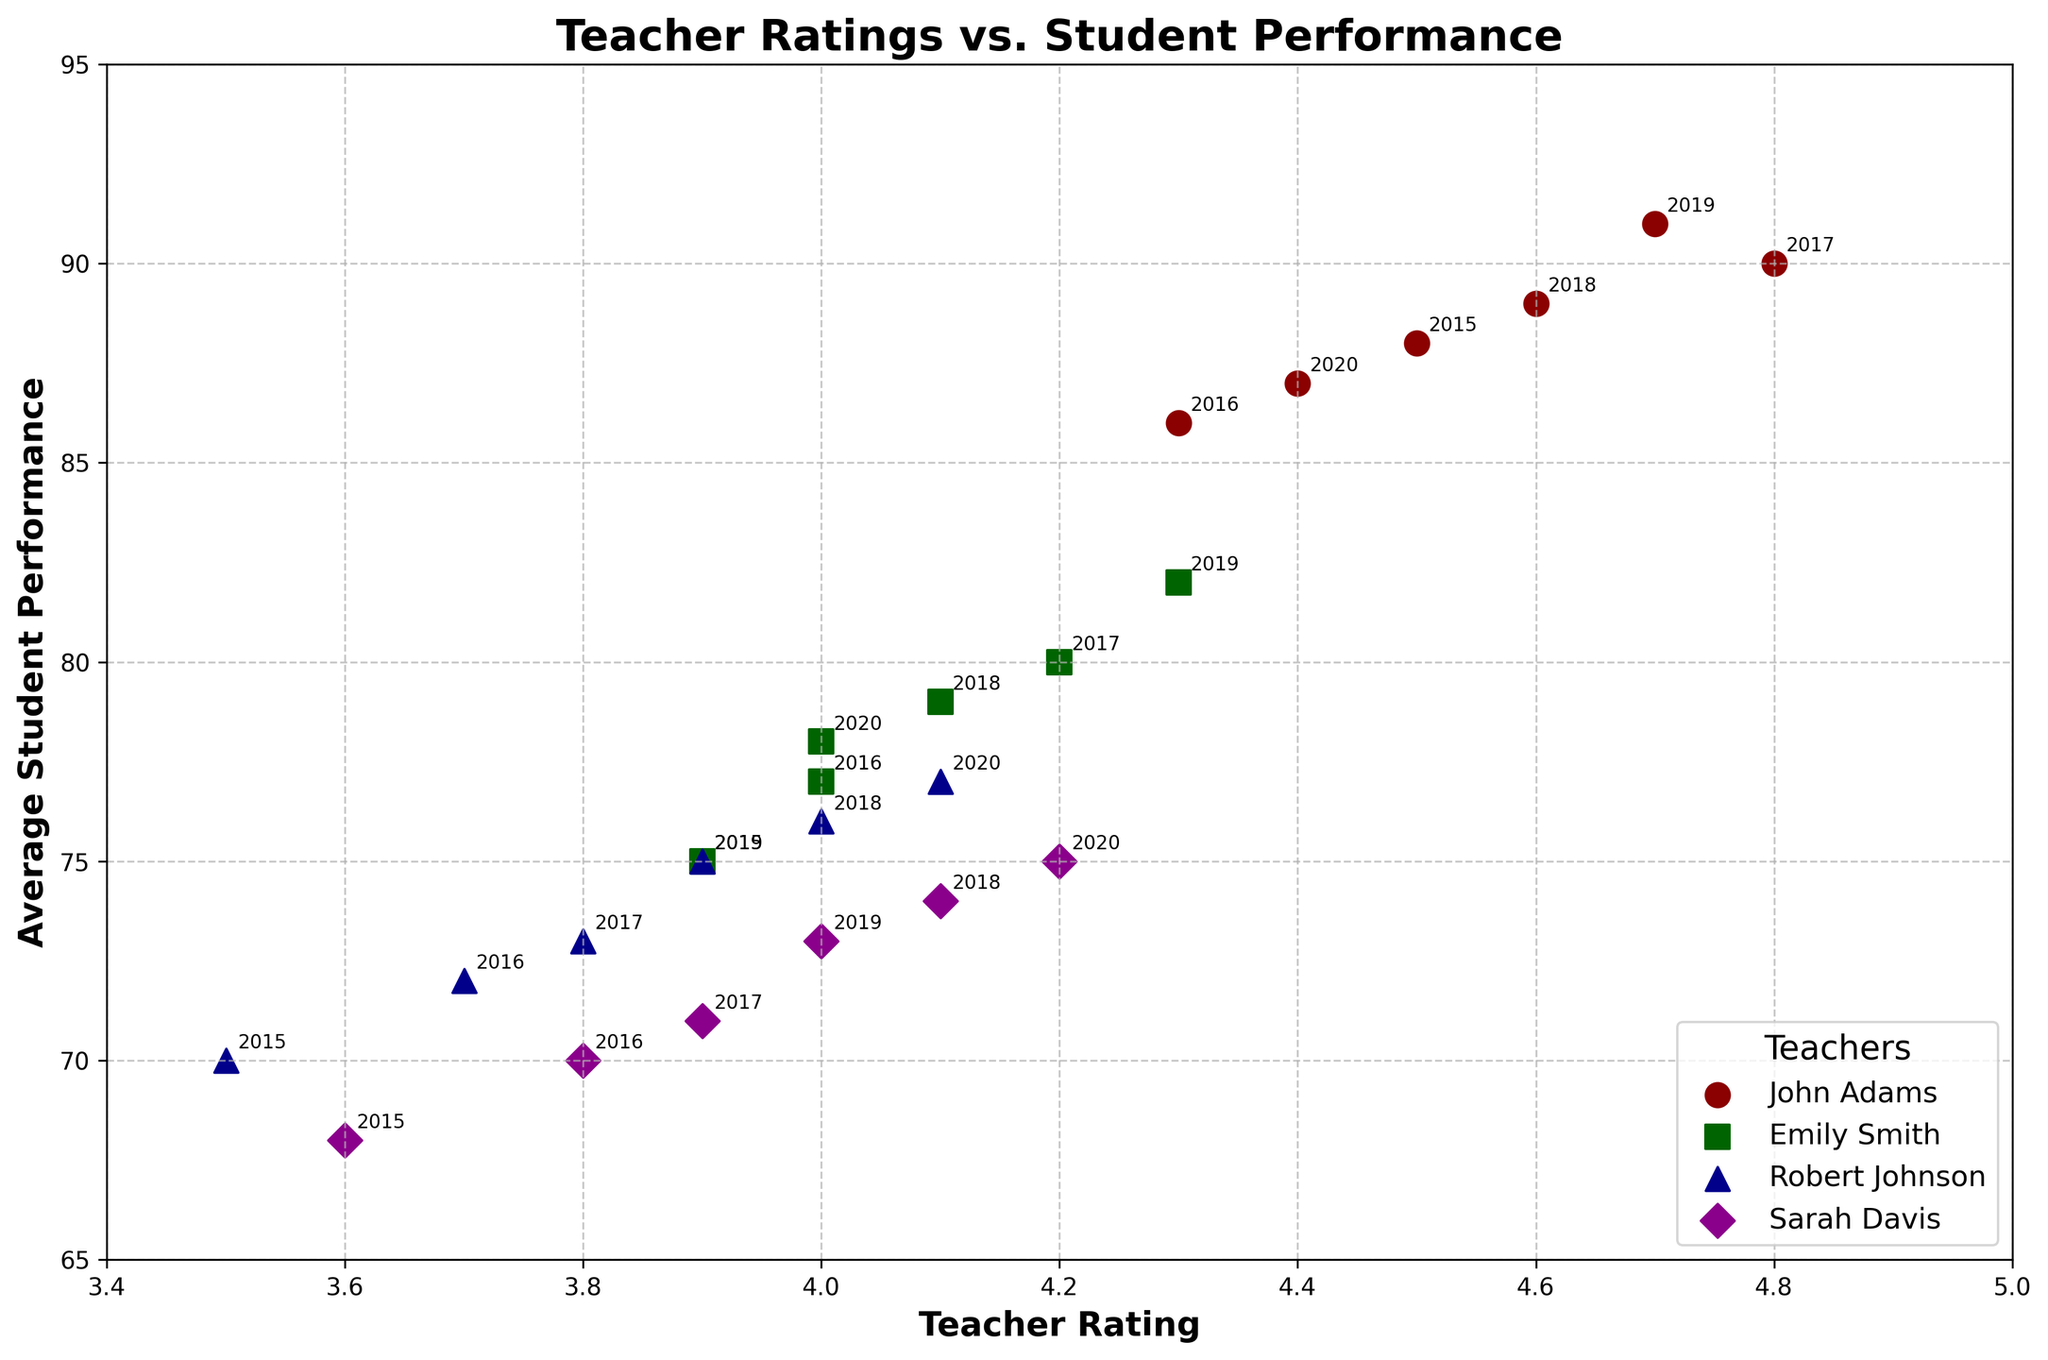What is the title of the figure? The title of the figure is displayed at the top and reads "Teacher Ratings vs. Student Performance."
Answer: Teacher Ratings vs. Student Performance What is the range of Teacher Ratings on the x-axis? The x-axis represents Teacher Ratings and ranges from approximately 3.4 to 5.0.
Answer: 3.4 to 5.0 Which teacher has the highest average student performance in any year? John Adams has the highest average student performance in 2019 with a score of 91, which is shown at the topmost point of the plot within his data points.
Answer: John Adams How many teachers are represented in this scatter plot? There are four different teachers represented in the scatter plot, which are indicated by distinct markers and colors.
Answer: Four Which teacher had the most consistent student performance over the years? To determine consistency, look for the teacher whose points are closely clustered. John Adams' points are relatively close, ranging from 86 to 91, indicating the most consistency.
Answer: John Adams Compare the average student performance in 2015 for Emily Smith and Robert Johnson. Who performed better? In 2015, Emily Smith had an average student performance of 75, while Robert Johnson had 70. Therefore, Emily Smith performed better.
Answer: Emily Smith For which teacher do the ratings and student performance seem to increase over time? By looking at the trends, Robert Johnson's ratings and student performance both generally increase from 2015 to 2020.
Answer: Robert Johnson What is the average Teacher Rating for Sarah Davis across the years? To find the average, sum up Sarah Davis' ratings for all years (3.6 + 3.8 + 3.9 + 4.1 + 4.0 + 4.2 = 23.6) and divide by the number of years (6). The average rating is therefore 3.93.
Answer: 3.93 Between 2017 and 2018, which teacher showed an improvement in their student performance? John Adams (90 to 89), Emily Smith (80 to 79), and Sarah Davis (71 to 74) showed no improvement or a decline. Robert Johnson showed an improvement from 73 to 76.
Answer: Robert Johnson What is the trend for Emily Smith's ratings and student performance from 2015 to 2020? Emily Smith's ratings show slight fluctuations but generally increase from 3.9 to 4.3 and then fall to 4.0. Her student performance shows a similar pattern, growing from 75 to 82 in 2019 and then falling to 78 in 2020.
Answer: Fluctuating 